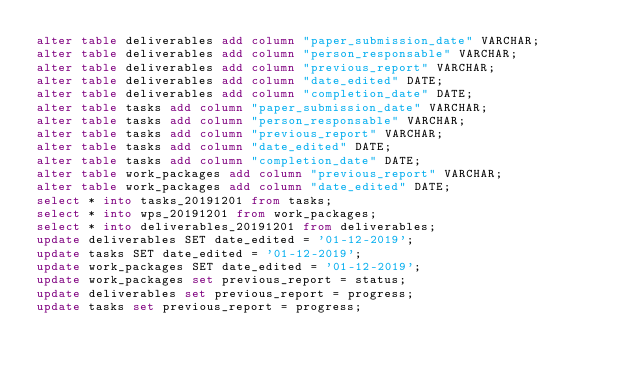Convert code to text. <code><loc_0><loc_0><loc_500><loc_500><_SQL_>alter table deliverables add column "paper_submission_date" VARCHAR;
alter table deliverables add column "person_responsable" VARCHAR;
alter table deliverables add column "previous_report" VARCHAR;
alter table deliverables add column "date_edited" DATE;
alter table deliverables add column "completion_date" DATE;
alter table tasks add column "paper_submission_date" VARCHAR;
alter table tasks add column "person_responsable" VARCHAR;
alter table tasks add column "previous_report" VARCHAR;
alter table tasks add column "date_edited" DATE;
alter table tasks add column "completion_date" DATE;
alter table work_packages add column "previous_report" VARCHAR;
alter table work_packages add column "date_edited" DATE;
select * into tasks_20191201 from tasks;
select * into wps_20191201 from work_packages;
select * into deliverables_20191201 from deliverables;
update deliverables SET date_edited = '01-12-2019';
update tasks SET date_edited = '01-12-2019';
update work_packages SET date_edited = '01-12-2019';
update work_packages set previous_report = status;
update deliverables set previous_report = progress;
update tasks set previous_report = progress;
</code> 